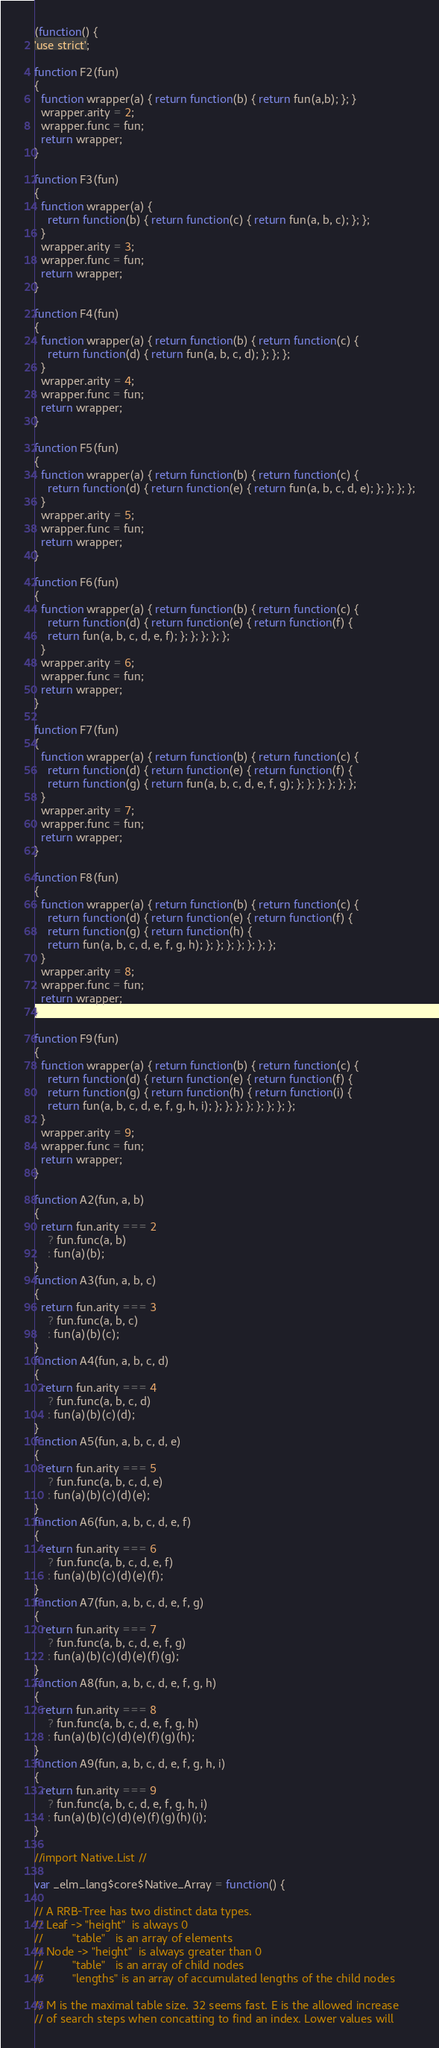Convert code to text. <code><loc_0><loc_0><loc_500><loc_500><_JavaScript_>
(function() {
'use strict';

function F2(fun)
{
  function wrapper(a) { return function(b) { return fun(a,b); }; }
  wrapper.arity = 2;
  wrapper.func = fun;
  return wrapper;
}

function F3(fun)
{
  function wrapper(a) {
    return function(b) { return function(c) { return fun(a, b, c); }; };
  }
  wrapper.arity = 3;
  wrapper.func = fun;
  return wrapper;
}

function F4(fun)
{
  function wrapper(a) { return function(b) { return function(c) {
    return function(d) { return fun(a, b, c, d); }; }; };
  }
  wrapper.arity = 4;
  wrapper.func = fun;
  return wrapper;
}

function F5(fun)
{
  function wrapper(a) { return function(b) { return function(c) {
    return function(d) { return function(e) { return fun(a, b, c, d, e); }; }; }; };
  }
  wrapper.arity = 5;
  wrapper.func = fun;
  return wrapper;
}

function F6(fun)
{
  function wrapper(a) { return function(b) { return function(c) {
    return function(d) { return function(e) { return function(f) {
    return fun(a, b, c, d, e, f); }; }; }; }; };
  }
  wrapper.arity = 6;
  wrapper.func = fun;
  return wrapper;
}

function F7(fun)
{
  function wrapper(a) { return function(b) { return function(c) {
    return function(d) { return function(e) { return function(f) {
    return function(g) { return fun(a, b, c, d, e, f, g); }; }; }; }; }; };
  }
  wrapper.arity = 7;
  wrapper.func = fun;
  return wrapper;
}

function F8(fun)
{
  function wrapper(a) { return function(b) { return function(c) {
    return function(d) { return function(e) { return function(f) {
    return function(g) { return function(h) {
    return fun(a, b, c, d, e, f, g, h); }; }; }; }; }; }; };
  }
  wrapper.arity = 8;
  wrapper.func = fun;
  return wrapper;
}

function F9(fun)
{
  function wrapper(a) { return function(b) { return function(c) {
    return function(d) { return function(e) { return function(f) {
    return function(g) { return function(h) { return function(i) {
    return fun(a, b, c, d, e, f, g, h, i); }; }; }; }; }; }; }; };
  }
  wrapper.arity = 9;
  wrapper.func = fun;
  return wrapper;
}

function A2(fun, a, b)
{
  return fun.arity === 2
    ? fun.func(a, b)
    : fun(a)(b);
}
function A3(fun, a, b, c)
{
  return fun.arity === 3
    ? fun.func(a, b, c)
    : fun(a)(b)(c);
}
function A4(fun, a, b, c, d)
{
  return fun.arity === 4
    ? fun.func(a, b, c, d)
    : fun(a)(b)(c)(d);
}
function A5(fun, a, b, c, d, e)
{
  return fun.arity === 5
    ? fun.func(a, b, c, d, e)
    : fun(a)(b)(c)(d)(e);
}
function A6(fun, a, b, c, d, e, f)
{
  return fun.arity === 6
    ? fun.func(a, b, c, d, e, f)
    : fun(a)(b)(c)(d)(e)(f);
}
function A7(fun, a, b, c, d, e, f, g)
{
  return fun.arity === 7
    ? fun.func(a, b, c, d, e, f, g)
    : fun(a)(b)(c)(d)(e)(f)(g);
}
function A8(fun, a, b, c, d, e, f, g, h)
{
  return fun.arity === 8
    ? fun.func(a, b, c, d, e, f, g, h)
    : fun(a)(b)(c)(d)(e)(f)(g)(h);
}
function A9(fun, a, b, c, d, e, f, g, h, i)
{
  return fun.arity === 9
    ? fun.func(a, b, c, d, e, f, g, h, i)
    : fun(a)(b)(c)(d)(e)(f)(g)(h)(i);
}

//import Native.List //

var _elm_lang$core$Native_Array = function() {

// A RRB-Tree has two distinct data types.
// Leaf -> "height"  is always 0
//         "table"   is an array of elements
// Node -> "height"  is always greater than 0
//         "table"   is an array of child nodes
//         "lengths" is an array of accumulated lengths of the child nodes

// M is the maximal table size. 32 seems fast. E is the allowed increase
// of search steps when concatting to find an index. Lower values will</code> 